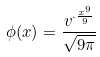<formula> <loc_0><loc_0><loc_500><loc_500>\phi ( x ) = \frac { v ^ { \cdot \frac { x ^ { 9 } } { 9 } } } { \sqrt { 9 \pi } }</formula> 